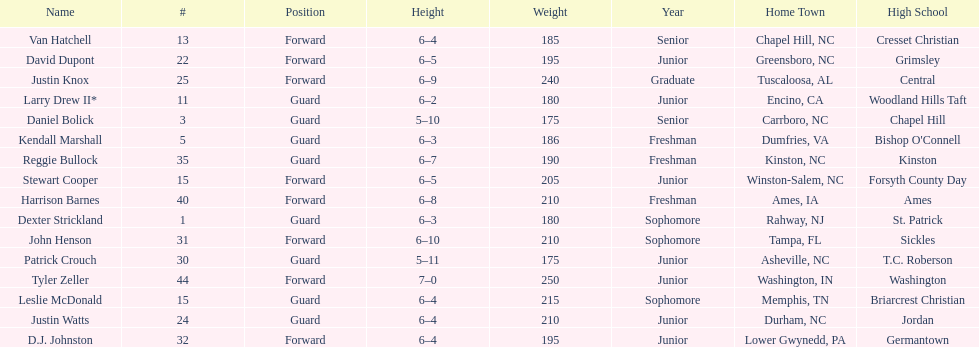How many players are not a junior? 9. 